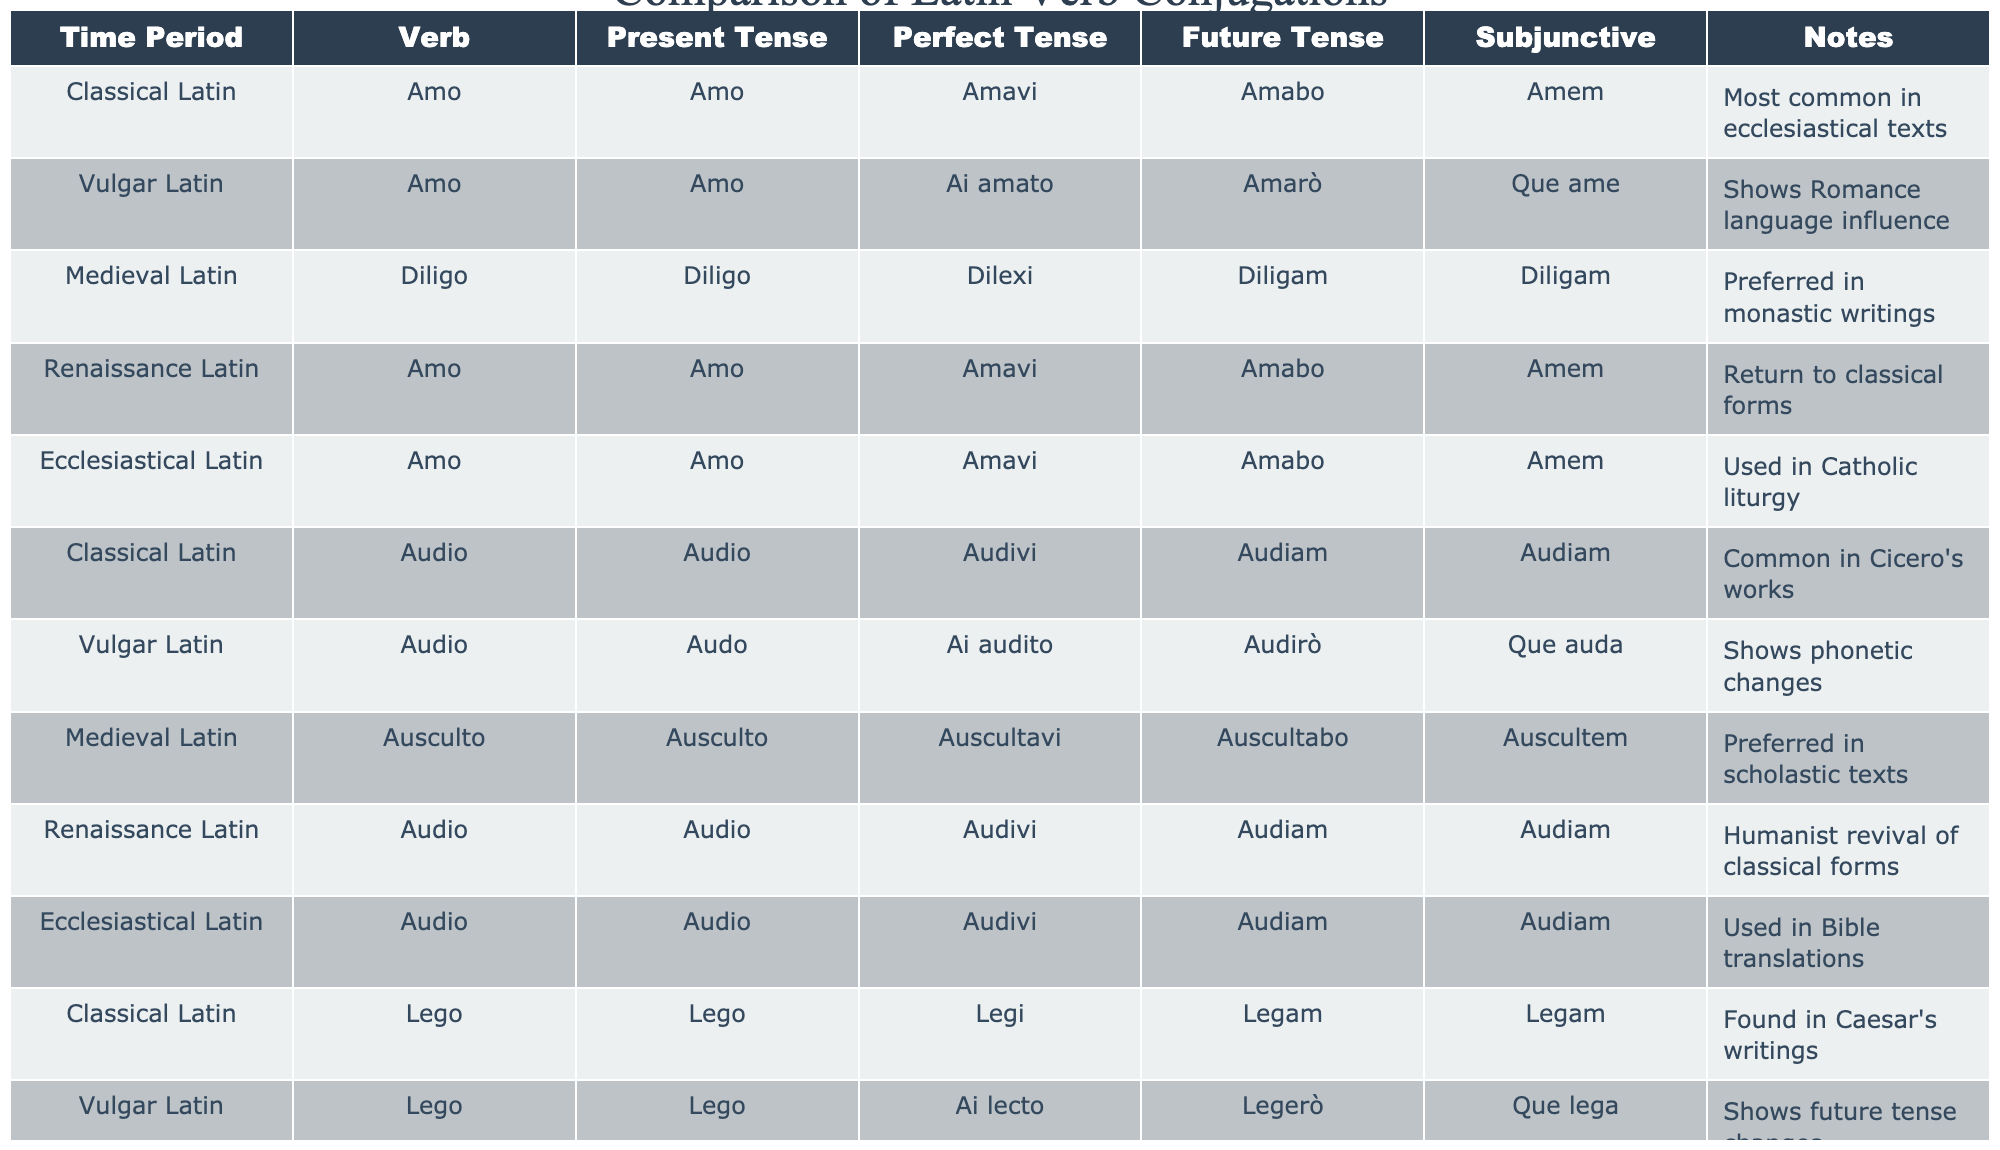What is the Present Tense form of the verb "Amo" in Classical Latin? The table indicates that the Present Tense form of "Amo" in Classical Latin is "Amo".
Answer: Amo Which verb has the Perfect Tense form "Dilexi"? According to the table, the verb with the Perfect Tense form "Dilexi" is "Diligo" from the Medieval Latin time period.
Answer: Diligo Do all time periods list the same Present Tense form for "Audio"? The table shows that all entries for "Audio" in different time periods indeed have the same Present Tense form, which is "Audio".
Answer: Yes What is the Perfect Tense form of "Lego" in Ecclesiastical Latin? The table specifies that the Perfect Tense form of "Lego" in Ecclesiastical Latin is "Legi".
Answer: Legi How many unique verbs are represented in the table? By counting the distinct verbs listed ("Amo", "Audio", "Lego", "Diligo", "Ausculto"), we find there are 5 unique verbs in total.
Answer: 5 Does Vulgar Latin show any influence from Romance languages, according to the notes? The notes for Vulgar Latin indicate that it shows Romance language influence, confirming the statement.
Answer: Yes What is the difference between the Perfect Tense form of "Amo" in Classical Latin and Renaissance Latin? Both periods list the same Perfect Tense form for "Amo", which is "Amavi", showing no difference in this aspect.
Answer: No difference Which tense of "Amo" in Renaissance Latin seems to revert back to classical forms? The table mentions that the Present Tense form "Amo" in Renaissance Latin is a return to classical forms, suggesting a revival.
Answer: Present Tense What observation can be made about the Future Tense forms across different time periods for the verb "Lego"? The Future Tense form "Legam" is consistently noted for "Lego" across Classical Latin, Renaissance Latin, and Ecclesiastical Latin, showing stability in its conjugation.
Answer: Consistency For the verb "Audio", how do the Perfect Tense forms differ between Vulgar Latin and Renaissance Latin? The table reveals that the Perfect Tense form for "Audio" is "Audivi" for Renaissance Latin and "Ai audito" for Vulgar Latin, indicating a clear difference in the forms.
Answer: They differ 